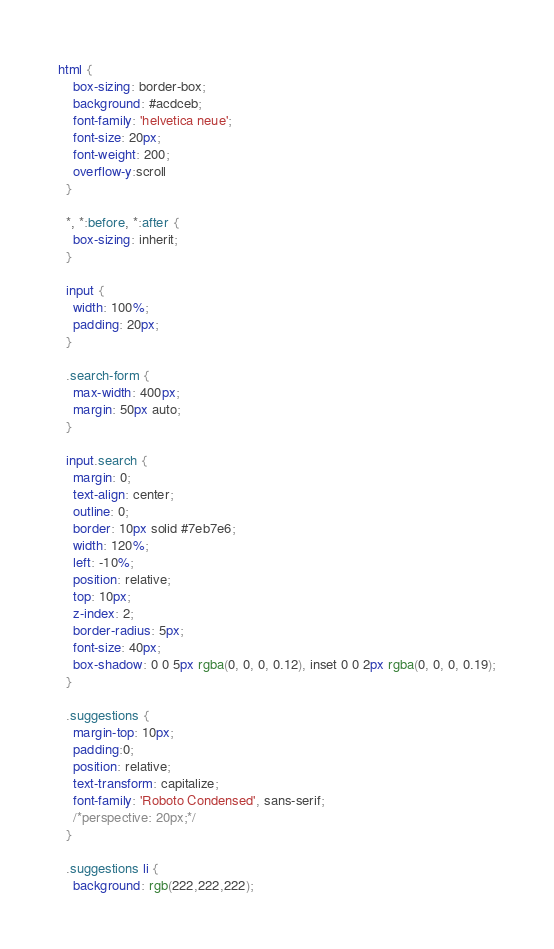<code> <loc_0><loc_0><loc_500><loc_500><_CSS_>html {
    box-sizing: border-box;
    background: #acdceb;
    font-family: 'helvetica neue';
    font-size: 20px;
    font-weight: 200;
    overflow-y:scroll
  }
  
  *, *:before, *:after {
    box-sizing: inherit;
  }

  input {
    width: 100%;
    padding: 20px;
  }
  
  .search-form {
    max-width: 400px;
    margin: 50px auto;
  }
  
  input.search {
    margin: 0;
    text-align: center;
    outline: 0;
    border: 10px solid #7eb7e6;
    width: 120%;
    left: -10%;
    position: relative;
    top: 10px;
    z-index: 2;
    border-radius: 5px;
    font-size: 40px;
    box-shadow: 0 0 5px rgba(0, 0, 0, 0.12), inset 0 0 2px rgba(0, 0, 0, 0.19);
  }
  
  .suggestions {
    margin-top: 10px;
    padding:0;
    position: relative;
    text-transform: capitalize;
    font-family: 'Roboto Condensed', sans-serif;
    /*perspective: 20px;*/
  }
  
  .suggestions li {
    background: rgb(222,222,222);</code> 